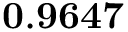Convert formula to latex. <formula><loc_0><loc_0><loc_500><loc_500>0 . 9 6 4 7</formula> 